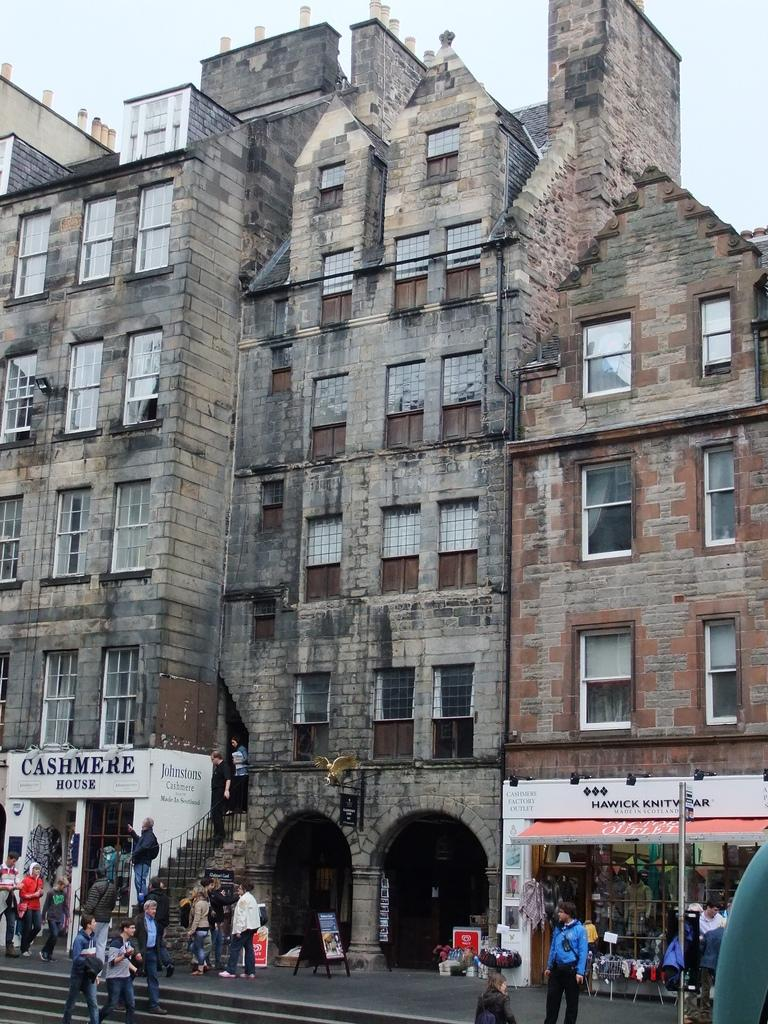Who or what can be seen in the image? There are people in the image. What type of structures are present in the image? There are buildings with windows in the image. What kind of establishments can be found in the image? There are stores in the image. What decorative or informative items are visible in the image? There are posters in the image. What architectural feature is present in the image? There are stairs in the image. What part of the natural environment is visible in the image? The sky is visible in the image. Where is the gun placed on the table in the image? There is no gun or table present in the image. 